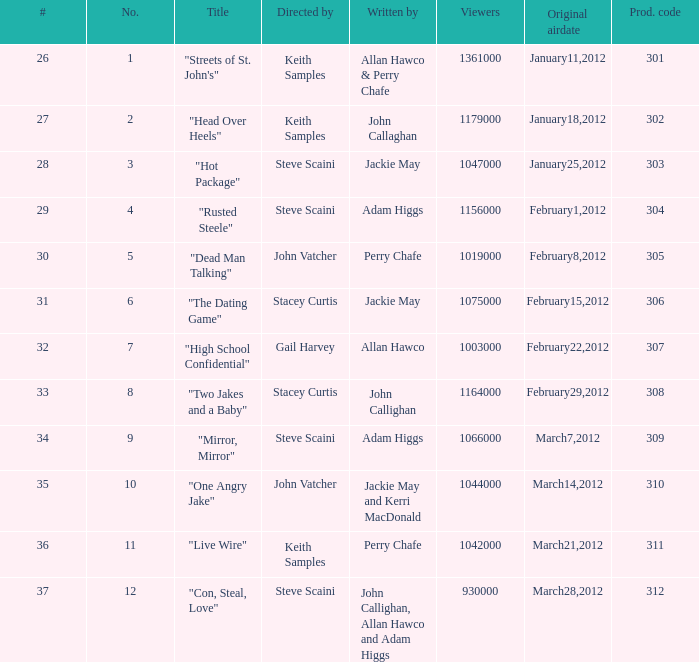What is the number of original airdate written by allan hawco? 1.0. 